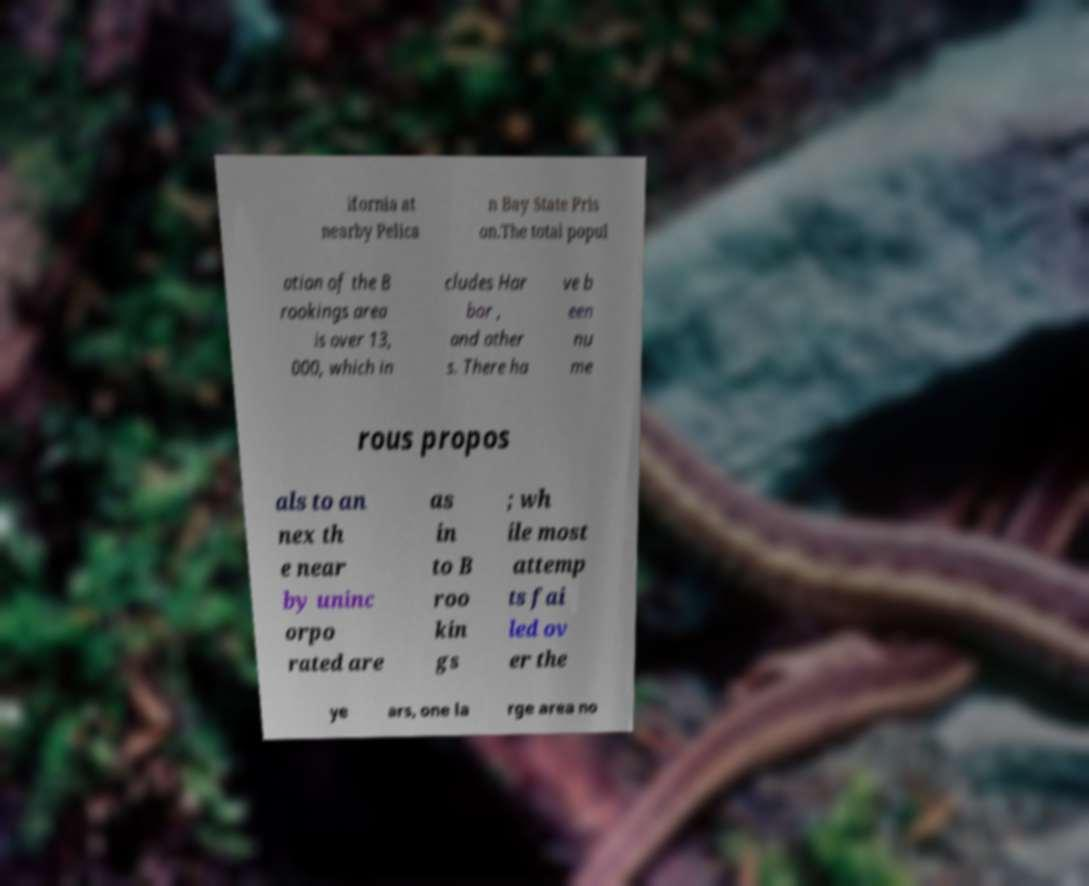Please read and relay the text visible in this image. What does it say? ifornia at nearby Pelica n Bay State Pris on.The total popul ation of the B rookings area is over 13, 000, which in cludes Har bor , and other s. There ha ve b een nu me rous propos als to an nex th e near by uninc orpo rated are as in to B roo kin gs ; wh ile most attemp ts fai led ov er the ye ars, one la rge area no 